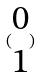<formula> <loc_0><loc_0><loc_500><loc_500>( \begin{matrix} 0 \\ 1 \end{matrix} )</formula> 